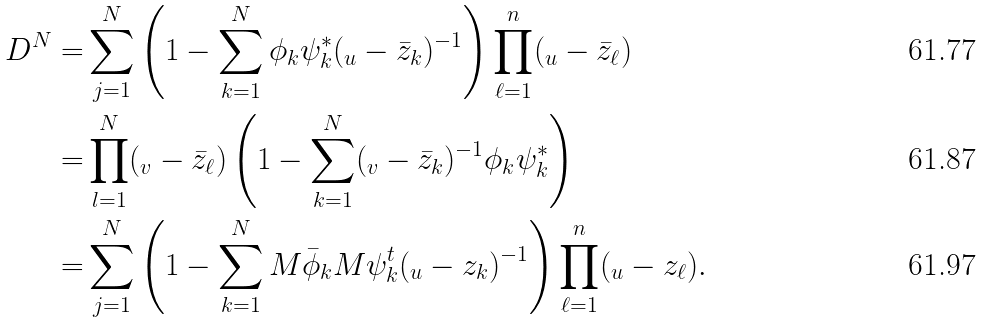Convert formula to latex. <formula><loc_0><loc_0><loc_500><loc_500>D ^ { N } = & \sum _ { j = 1 } ^ { N } \left ( 1 - \sum _ { k = 1 } ^ { N } \phi _ { k } \psi _ { k } ^ { * } ( \L _ { u } - \bar { z } _ { k } ) ^ { - 1 } \right ) \prod _ { \ell = 1 } ^ { n } ( \L _ { u } - \bar { z } _ { \ell } ) \\ = & \prod _ { l = 1 } ^ { N } ( \L _ { v } - \bar { z } _ { \ell } ) \left ( 1 - \sum _ { k = 1 } ^ { N } ( \L _ { v } - \bar { z } _ { k } ) ^ { - 1 } \phi _ { k } \psi _ { k } ^ { * } \right ) \\ = & \sum _ { j = 1 } ^ { N } \left ( 1 - \sum _ { k = 1 } ^ { N } M \bar { \phi } _ { k } M \psi _ { k } ^ { t } ( \L _ { u } - z _ { k } ) ^ { - 1 } \right ) \prod _ { \ell = 1 } ^ { n } ( \L _ { u } - z _ { \ell } ) .</formula> 